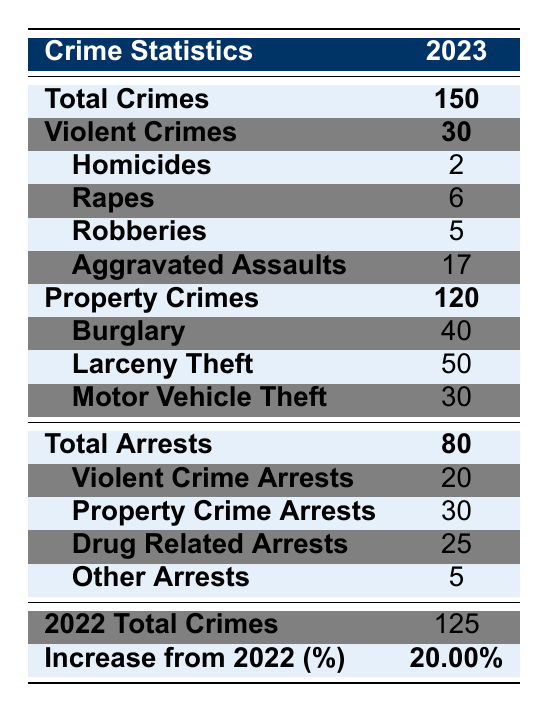What is the total number of crimes reported in Midlothian for 2023? The total number of crimes is clearly stated in the table under 'Total Crimes,' which is shown as 150.
Answer: 150 How many violent crimes were reported in Midlothian in 2023? The number of violent crimes is listed in the table under 'Violent Crimes,' showing a total of 30.
Answer: 30 What was the number of burglaries in 2023? The breakdown for property crimes includes a specific number for burglary, which is noted as 40 in the table.
Answer: 40 How many arrests were made for property crimes? The total number of arrests for property crimes is shown in the 'Property Crime Arrests' section, which indicates there were 30 arrests.
Answer: 30 Is there an increase in total crimes from 2022 to 2023? The table indicates a total of 125 crimes in 2022 and 150 in 2023, showing an increase.
Answer: Yes What percentage increase in total crimes occurred from 2022 to 2023? The percentage increase is shown in the table as 20%. This is calculated as (150 - 125) / 125 * 100 = 20%.
Answer: 20% What was the breakdown of violent crimes by type? The table provides a detailed breakdown: 2 homicides, 6 rapes, 5 robberies, and 17 aggravated assaults.
Answer: Homicides: 2, Rapes: 6, Robberies: 5, Aggravated Assaults: 17 How many more property crimes were reported in 2023 compared to 2022? In 2023, there were 120 property crimes, and in 2022, there were 97. The difference is 120 - 97 = 23 more property crimes.
Answer: 23 What is the total number of arrests made in 2023? The total arrests are summed under 'Total Arrests,' which is 80, showing all types of arrests combined.
Answer: 80 Did the number of drug-related arrests increase from 2022 to 2023? The table does not provide data from 2022 for drug-related arrests, so we cannot determine an increase.
Answer: Unknown 